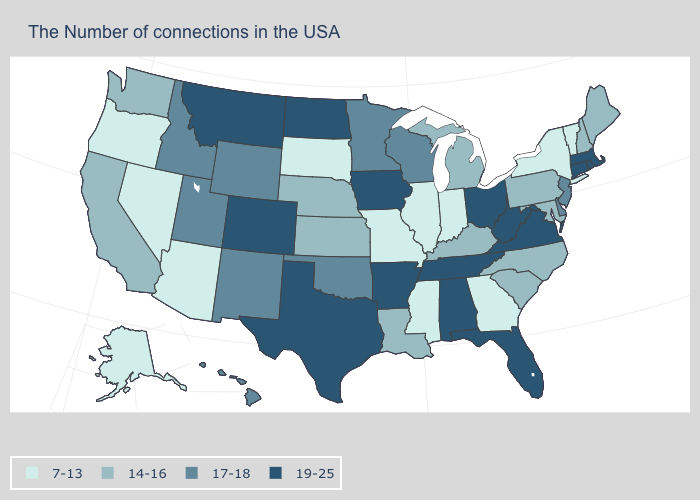Does Illinois have the highest value in the MidWest?
Short answer required. No. What is the value of Missouri?
Concise answer only. 7-13. Does New Jersey have a higher value than Oregon?
Short answer required. Yes. How many symbols are there in the legend?
Concise answer only. 4. What is the value of Iowa?
Short answer required. 19-25. What is the highest value in the West ?
Quick response, please. 19-25. Name the states that have a value in the range 17-18?
Concise answer only. New Jersey, Delaware, Wisconsin, Minnesota, Oklahoma, Wyoming, New Mexico, Utah, Idaho, Hawaii. What is the value of Michigan?
Give a very brief answer. 14-16. How many symbols are there in the legend?
Answer briefly. 4. Does Hawaii have the highest value in the USA?
Give a very brief answer. No. What is the value of Michigan?
Quick response, please. 14-16. Does Illinois have the same value as Colorado?
Be succinct. No. Does the map have missing data?
Short answer required. No. What is the value of Iowa?
Quick response, please. 19-25. Does the first symbol in the legend represent the smallest category?
Concise answer only. Yes. 